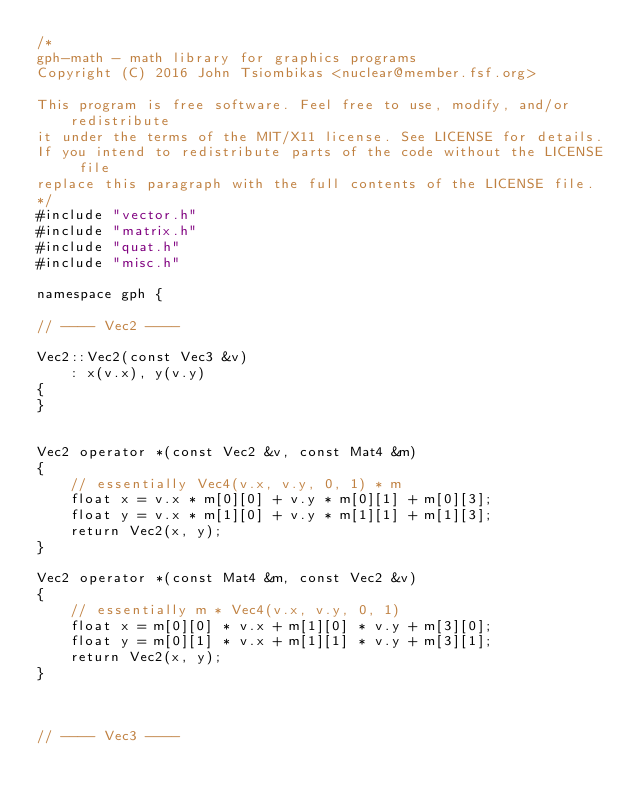<code> <loc_0><loc_0><loc_500><loc_500><_C++_>/*
gph-math - math library for graphics programs
Copyright (C) 2016 John Tsiombikas <nuclear@member.fsf.org>

This program is free software. Feel free to use, modify, and/or redistribute
it under the terms of the MIT/X11 license. See LICENSE for details.
If you intend to redistribute parts of the code without the LICENSE file
replace this paragraph with the full contents of the LICENSE file.
*/
#include "vector.h"
#include "matrix.h"
#include "quat.h"
#include "misc.h"

namespace gph {

// ---- Vec2 ----

Vec2::Vec2(const Vec3 &v)
	: x(v.x), y(v.y)
{
}


Vec2 operator *(const Vec2 &v, const Mat4 &m)
{
	// essentially Vec4(v.x, v.y, 0, 1) * m
	float x = v.x * m[0][0] + v.y * m[0][1] + m[0][3];
	float y = v.x * m[1][0] + v.y * m[1][1] + m[1][3];
	return Vec2(x, y);
}

Vec2 operator *(const Mat4 &m, const Vec2 &v)
{
	// essentially m * Vec4(v.x, v.y, 0, 1)
	float x = m[0][0] * v.x + m[1][0] * v.y + m[3][0];
	float y = m[0][1] * v.x + m[1][1] * v.y + m[3][1];
	return Vec2(x, y);
}



// ---- Vec3 ----
</code> 